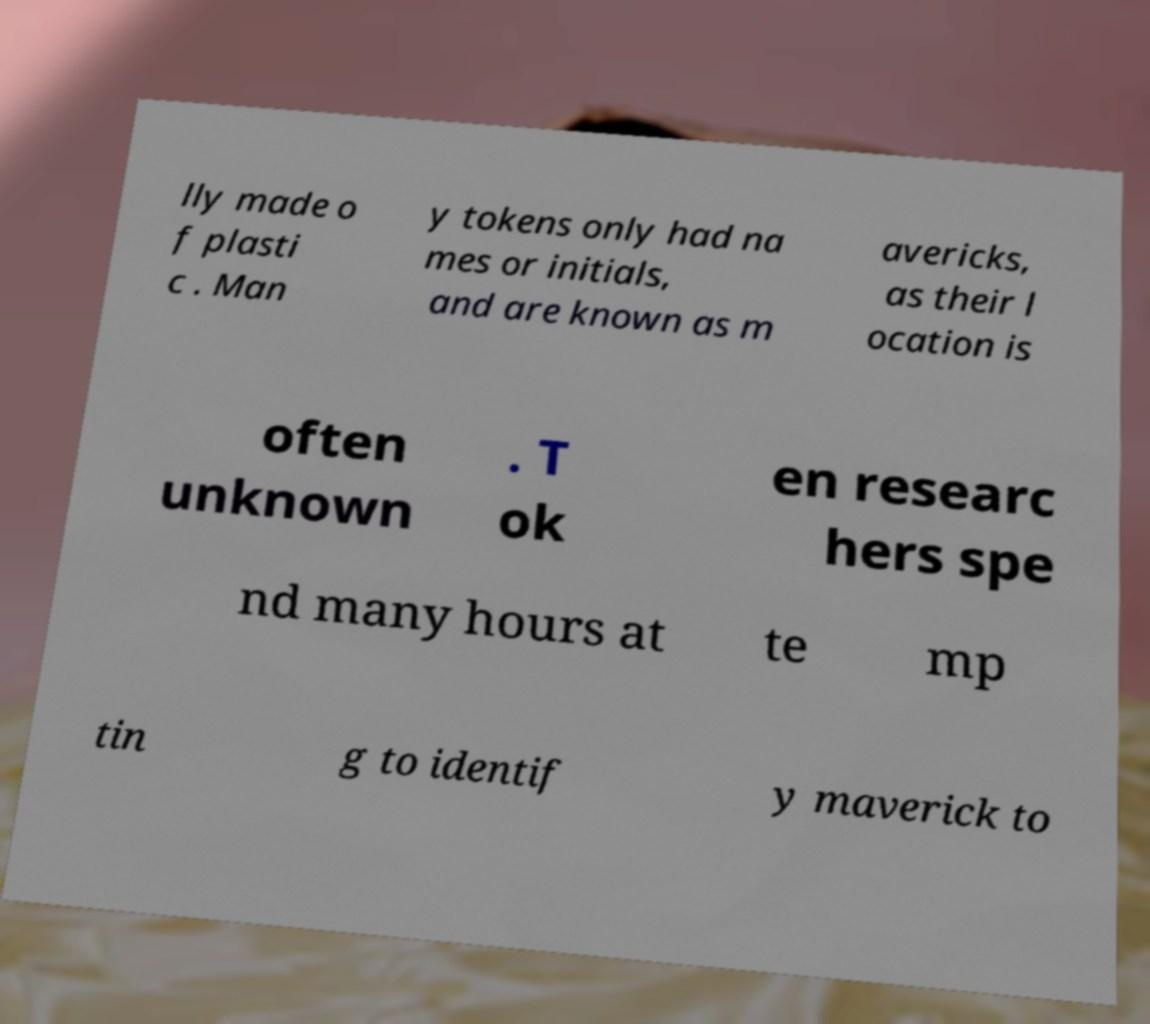For documentation purposes, I need the text within this image transcribed. Could you provide that? lly made o f plasti c . Man y tokens only had na mes or initials, and are known as m avericks, as their l ocation is often unknown . T ok en researc hers spe nd many hours at te mp tin g to identif y maverick to 